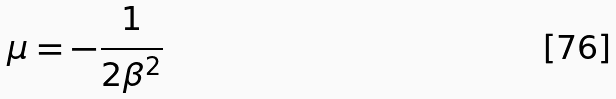Convert formula to latex. <formula><loc_0><loc_0><loc_500><loc_500>\mu = - \frac { 1 } { 2 \beta ^ { 2 } }</formula> 